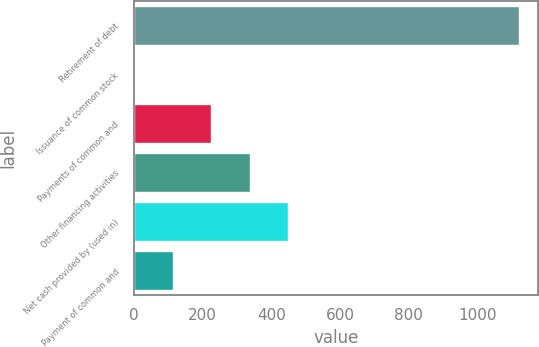Convert chart. <chart><loc_0><loc_0><loc_500><loc_500><bar_chart><fcel>Retirement of debt<fcel>Issuance of common stock<fcel>Payments of common and<fcel>Other financing activities<fcel>Net cash provided by (used in)<fcel>Payment of common and<nl><fcel>1121<fcel>1<fcel>225<fcel>337<fcel>449<fcel>113<nl></chart> 